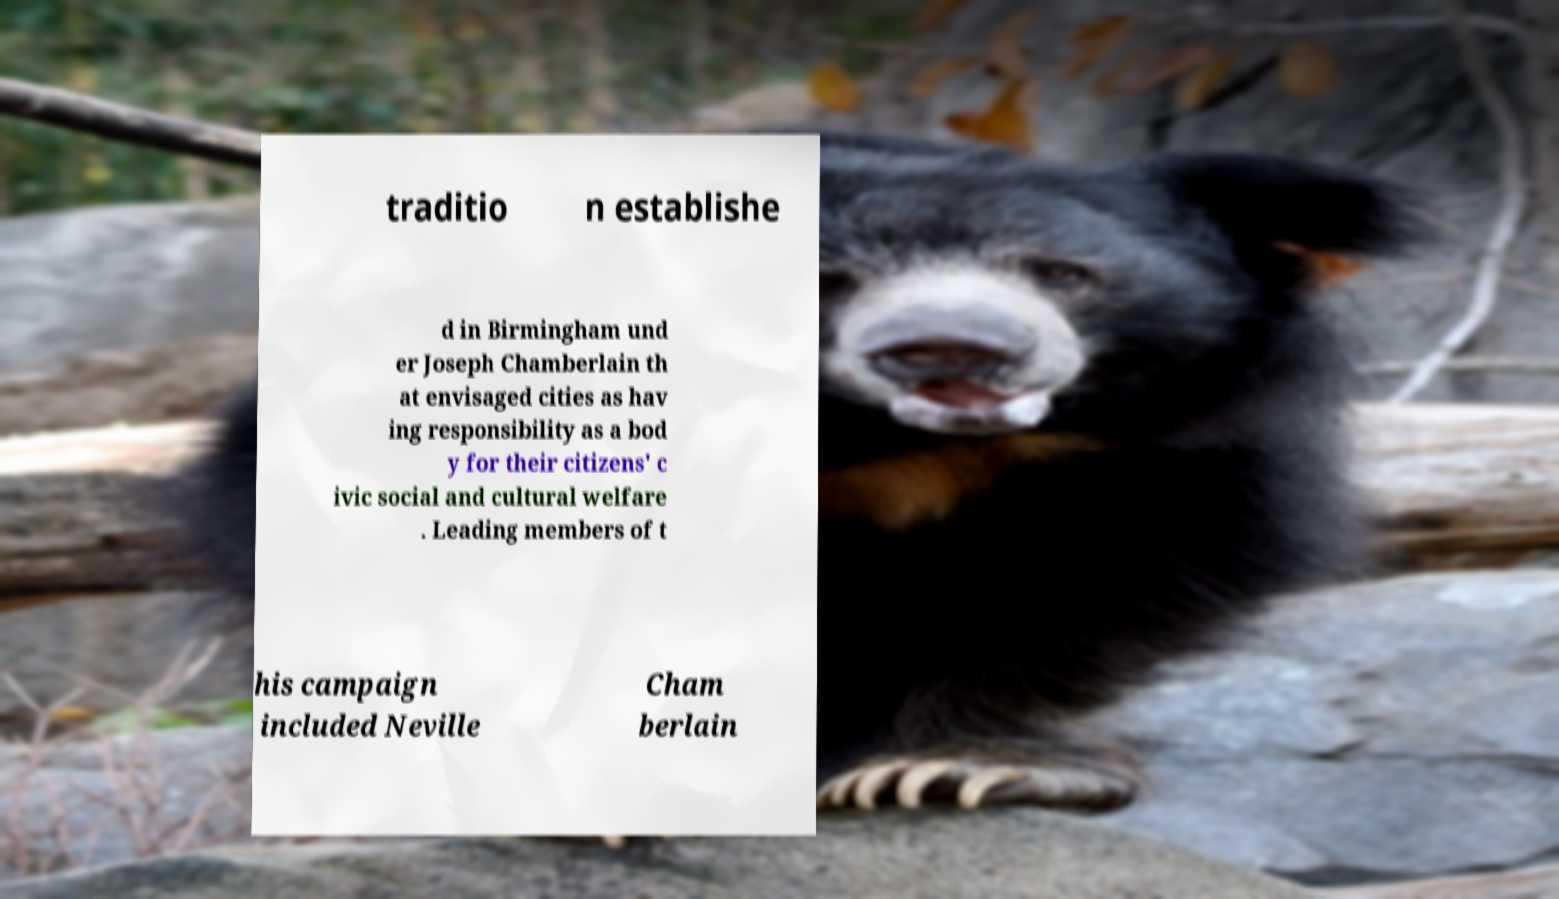What messages or text are displayed in this image? I need them in a readable, typed format. traditio n establishe d in Birmingham und er Joseph Chamberlain th at envisaged cities as hav ing responsibility as a bod y for their citizens' c ivic social and cultural welfare . Leading members of t his campaign included Neville Cham berlain 